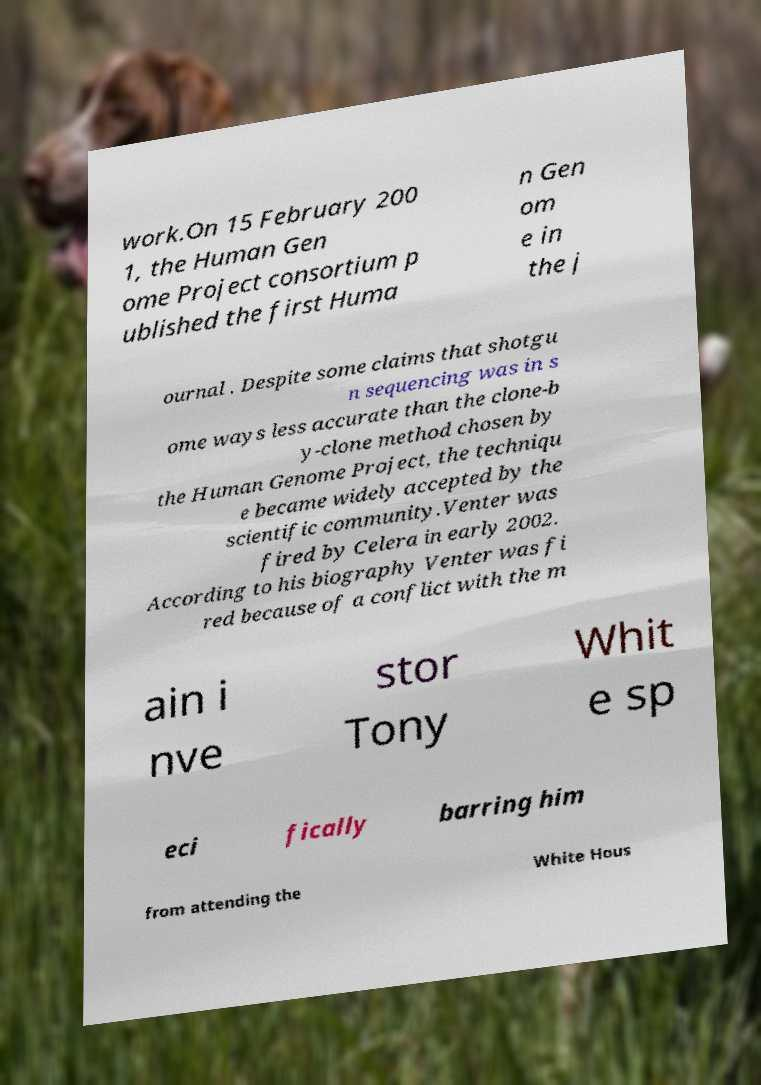Could you assist in decoding the text presented in this image and type it out clearly? work.On 15 February 200 1, the Human Gen ome Project consortium p ublished the first Huma n Gen om e in the j ournal . Despite some claims that shotgu n sequencing was in s ome ways less accurate than the clone-b y-clone method chosen by the Human Genome Project, the techniqu e became widely accepted by the scientific community.Venter was fired by Celera in early 2002. According to his biography Venter was fi red because of a conflict with the m ain i nve stor Tony Whit e sp eci fically barring him from attending the White Hous 